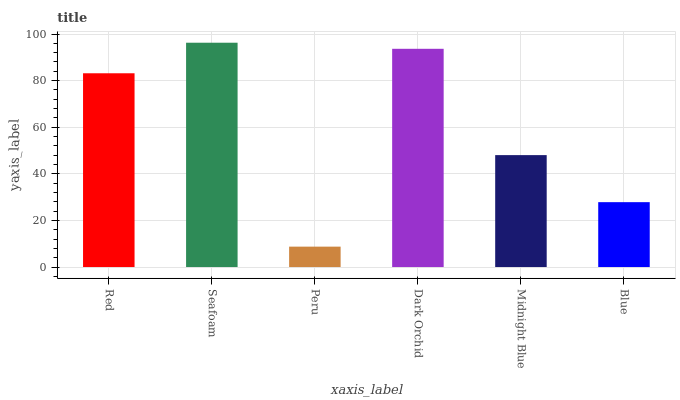Is Peru the minimum?
Answer yes or no. Yes. Is Seafoam the maximum?
Answer yes or no. Yes. Is Seafoam the minimum?
Answer yes or no. No. Is Peru the maximum?
Answer yes or no. No. Is Seafoam greater than Peru?
Answer yes or no. Yes. Is Peru less than Seafoam?
Answer yes or no. Yes. Is Peru greater than Seafoam?
Answer yes or no. No. Is Seafoam less than Peru?
Answer yes or no. No. Is Red the high median?
Answer yes or no. Yes. Is Midnight Blue the low median?
Answer yes or no. Yes. Is Blue the high median?
Answer yes or no. No. Is Peru the low median?
Answer yes or no. No. 